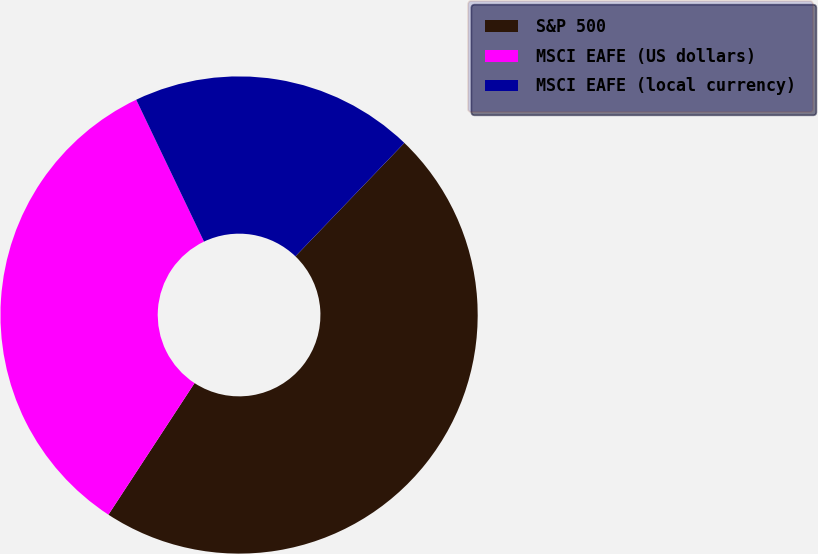<chart> <loc_0><loc_0><loc_500><loc_500><pie_chart><fcel>S&P 500<fcel>MSCI EAFE (US dollars)<fcel>MSCI EAFE (local currency)<nl><fcel>47.04%<fcel>33.68%<fcel>19.27%<nl></chart> 